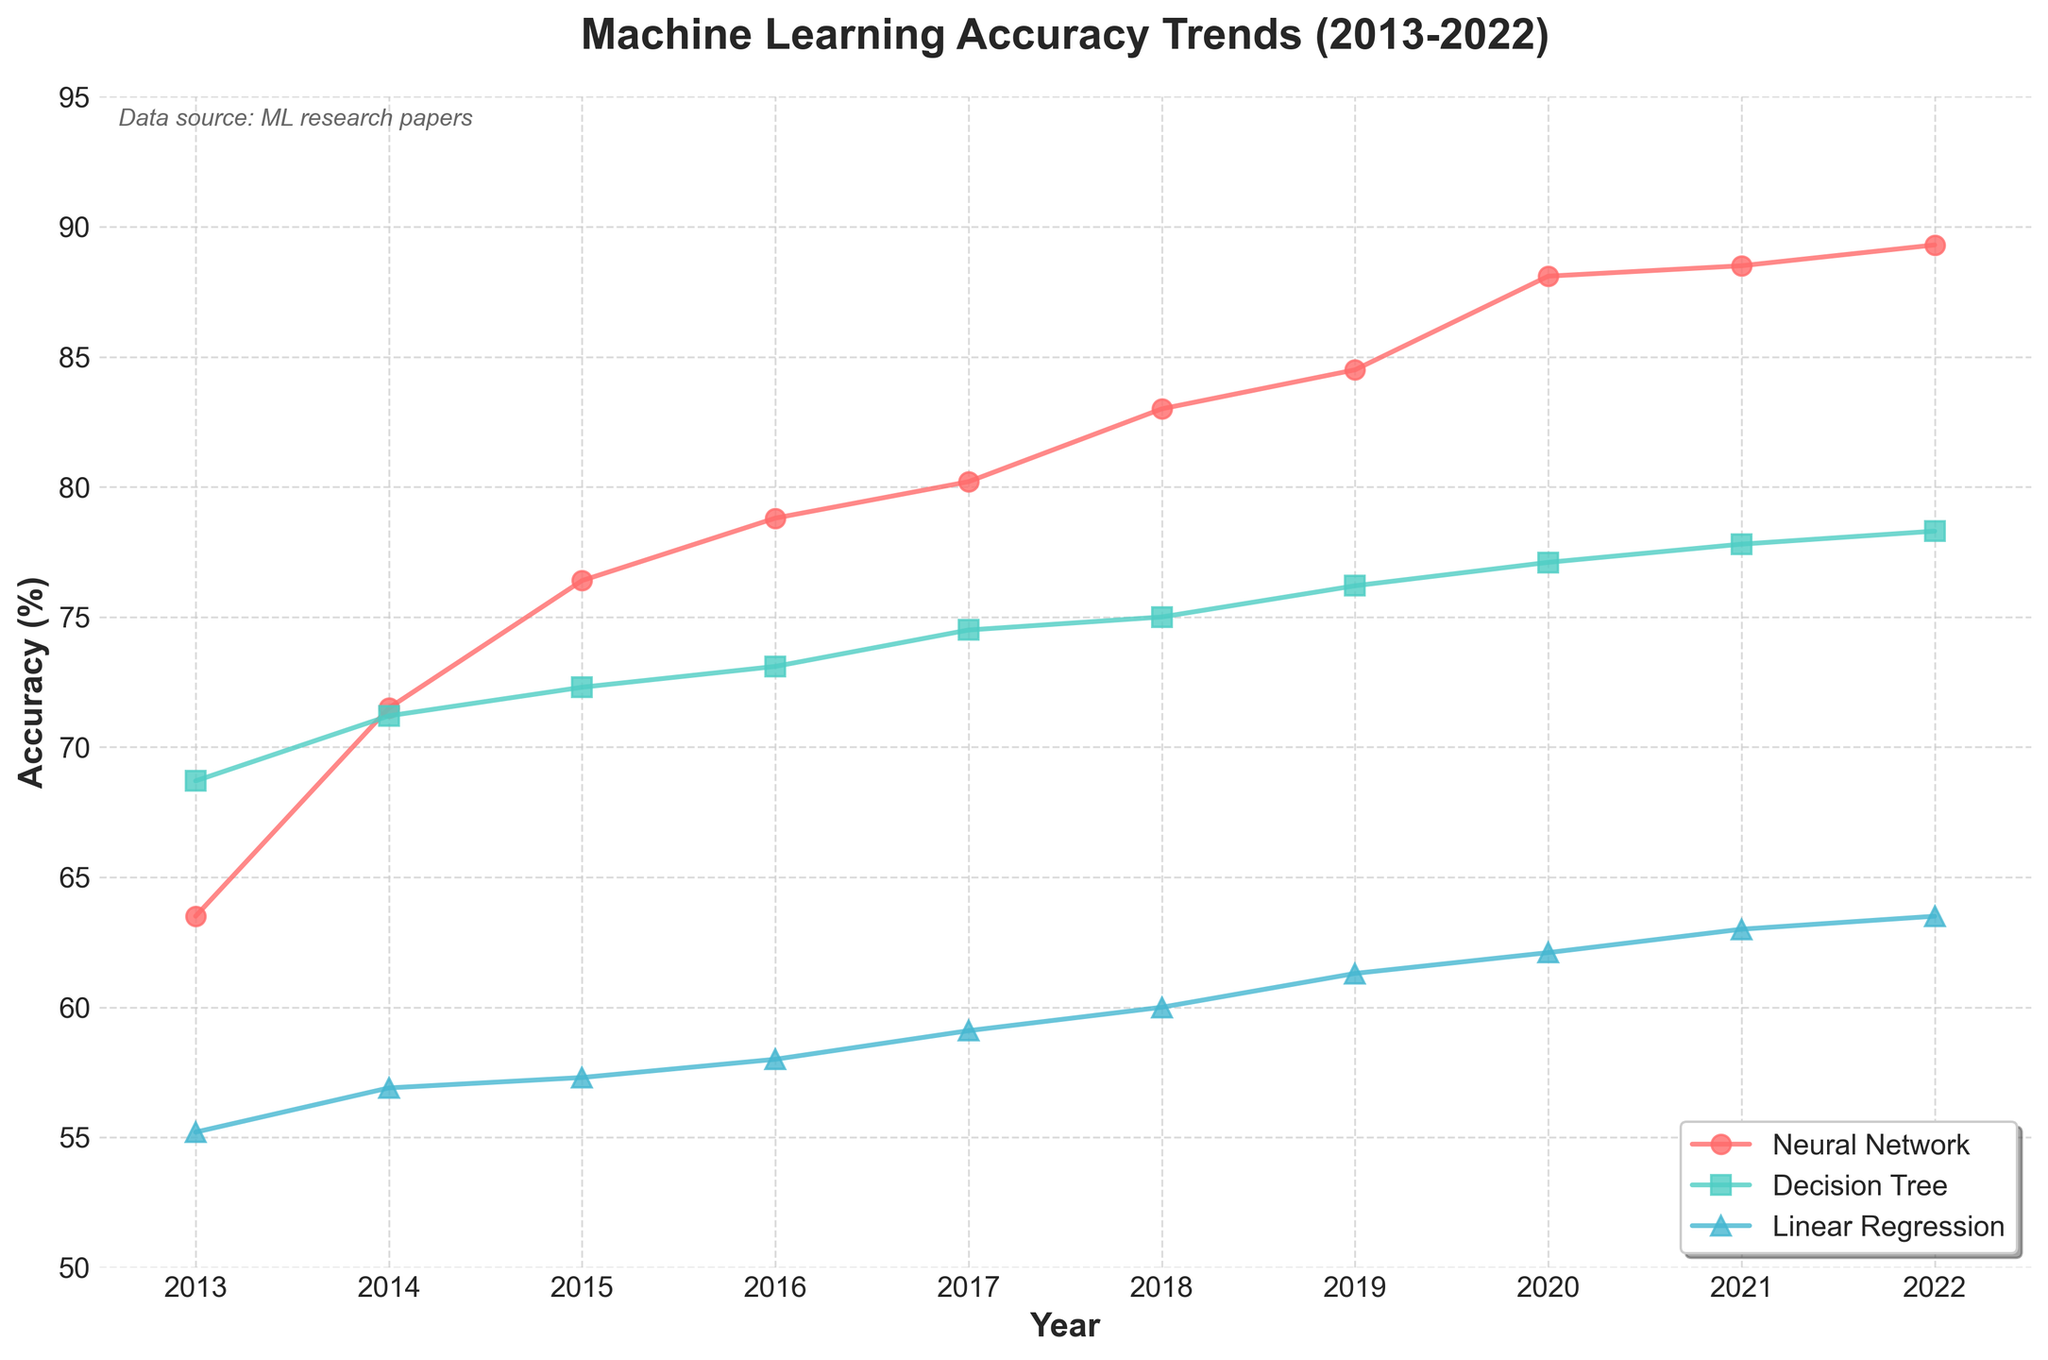What is the general trend of accuracy for neural network models from 2013 to 2022? Referring to the figure, the accuracy for neural network models shows a consistent increase over the period from 2013 to 2022. Each subsequent model outperforms the previous one in terms of accuracy.
Answer: The accuracy consistently increases Which year shows the most significant increase in accuracy for neural network models? From the figure, comparing year-to-year increases, the most significant jump in accuracy for neural network models occurs between 2019 (84.5 for BERT) and 2020 (88.1 for OpenAI GPT-3). The difference is 3.6 percentage points.
Answer: 2020 Between 2013 and 2022, how many data points (years) are represented for each technique? The time series plot covers the years 2013 to 2022, and each technique has a data point for every year in this range. Observing the plot, we count each marker for each technique and find there are ten data points per technique.
Answer: 10 Which technique had the highest accuracy in 2017? Referencing the plot for the year 2017, the neural network technique (DenseNet) has the highest accuracy compared to decision trees and linear regression models.
Answer: Neural network How does the accuracy of decision tree models compare to neural network models in 2018? By looking at the plot for the year 2018, the accuracy of the best decision tree model (LightGBM-tuned, 75.0) is lower than the accuracy of the best neural network model (EfficientNet, 83.0).
Answer: Lower What is the range of accuracy values for linear regression models from 2013 to 2022? Examining the figure, linear regression accuracy starts at 55.2 in 2013 (OLS) and goes up to 63.5 in 2022 (Huber Regressor). The range is given by subtracting the smallest accuracy from the largest accuracy: 63.5 - 55.2.
Answer: 8.3 Which year shows the largest increase in accuracy for decision tree models? From the figure, the largest year-on-year increase for decision tree models is between 2019 (76.2 for CATBoost-tuned) and 2020 (77.1 for XGBoost hyperopt), an increase of 0.9 percentage points.
Answer: 2020 In 2022, how do the accuracies of the three techniques compare? For the year 2022, neural networks (BYOLO) have the highest accuracy (89.3), followed by decision trees (CATBoost hyperopt, 78.3), and then linear regression (Huber Regressor, 63.5).
Answer: Neural networks > decision trees > linear regression What overall pattern can be observed in machine learning accuracy trends across all techniques from 2013 to 2022? Observing the figure, all techniques (neural networks, decision trees, and linear regression) show a general upward trend in accuracy from 2013 to 2022, with neural networks showing the most significant improvement, followed by decision trees and linear regression.
Answer: Upward trend for all techniques 